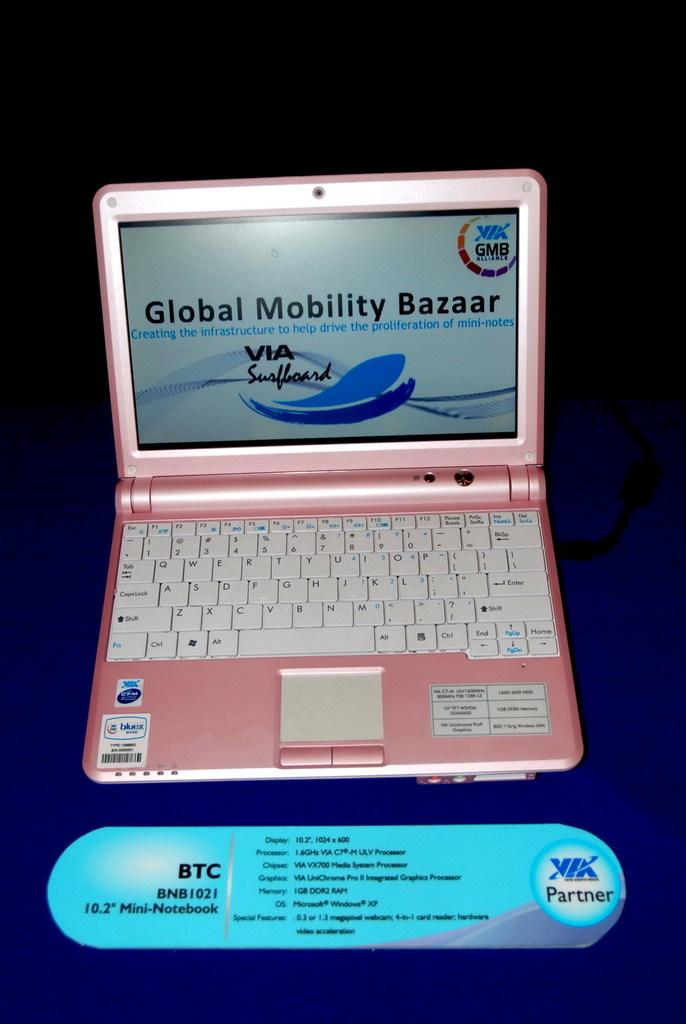<image>
Create a compact narrative representing the image presented. The pink laptop computer has Global Mobility Bazaar on the screen. 